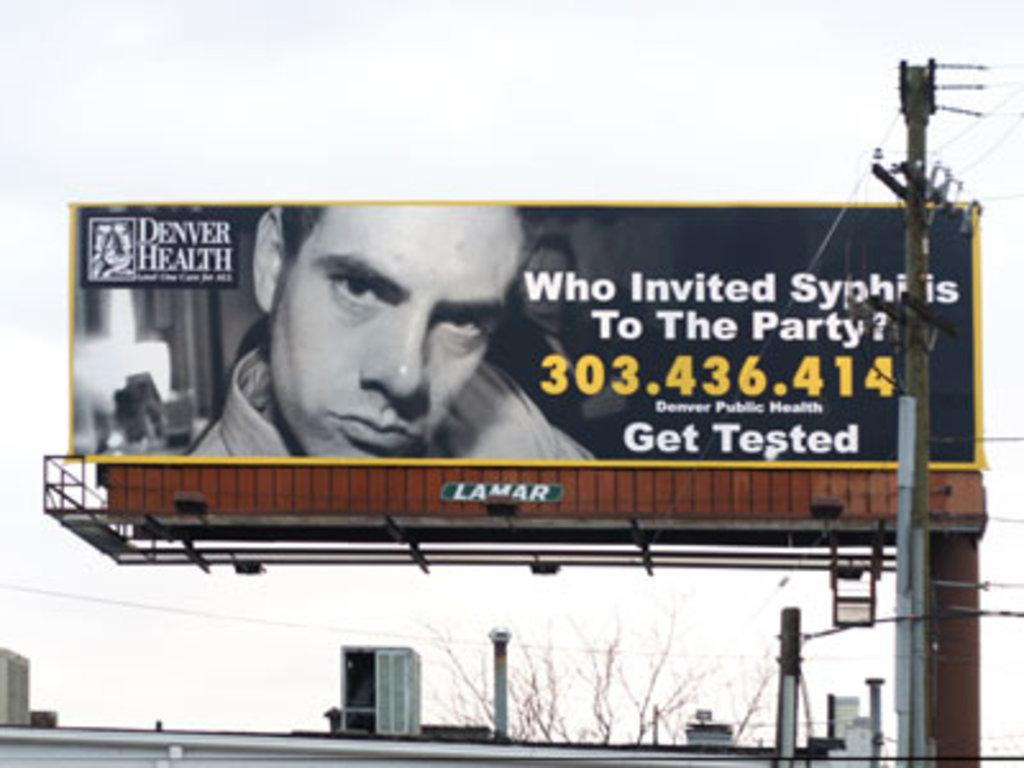<image>
Render a clear and concise summary of the photo. An advertisement regarding STDs is on a billboard with a phone number to contact. 